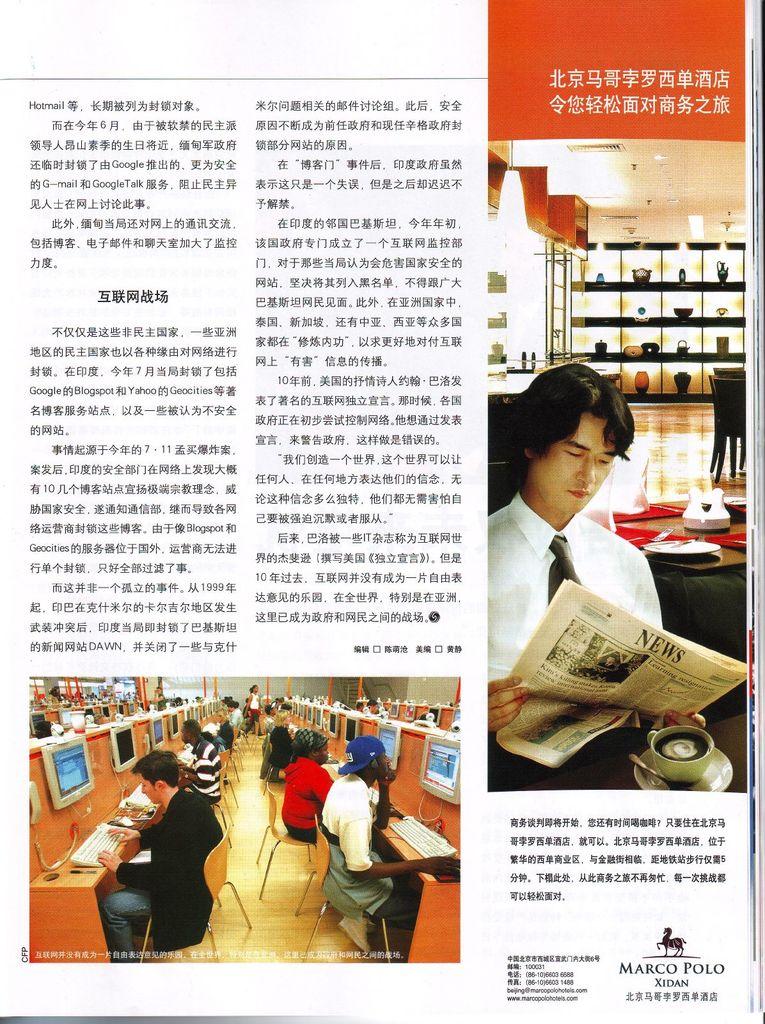What is the headline of the newspaper the man is reading?
Keep it short and to the point. News. What name is under the horse in the lower right hand corner?
Provide a short and direct response. Marco polo. 